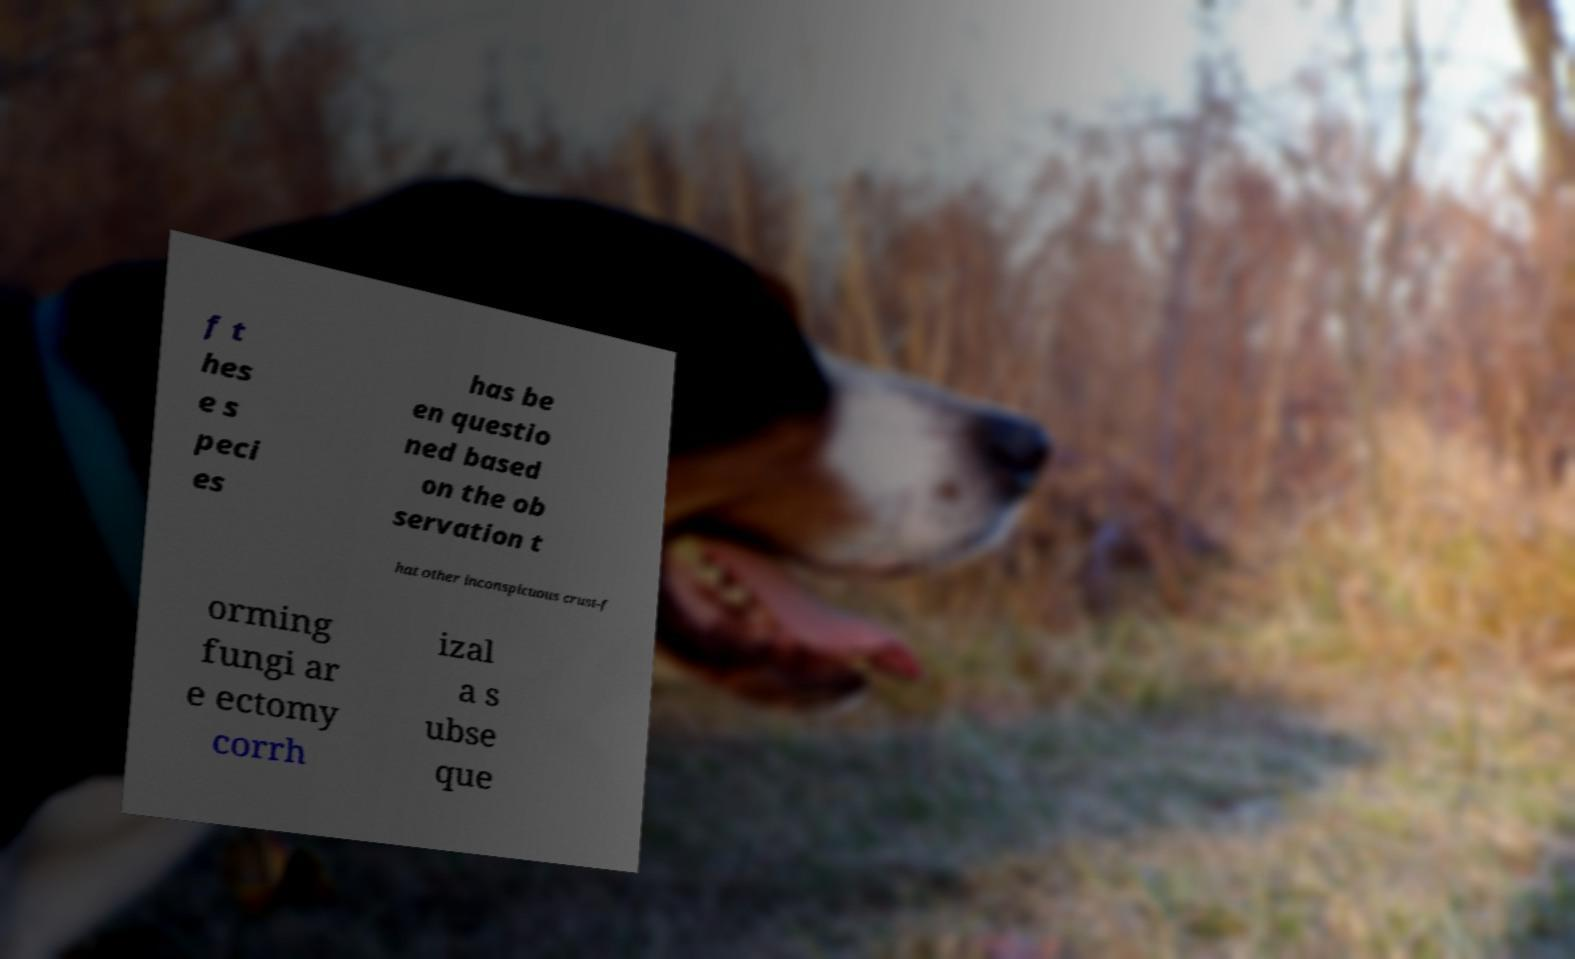Can you read and provide the text displayed in the image?This photo seems to have some interesting text. Can you extract and type it out for me? f t hes e s peci es has be en questio ned based on the ob servation t hat other inconspicuous crust-f orming fungi ar e ectomy corrh izal a s ubse que 